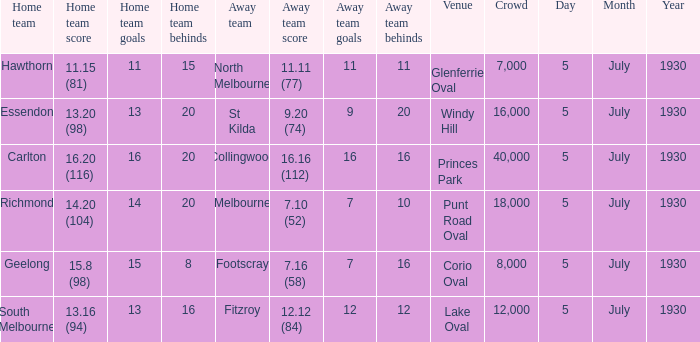When does the team have a game at punt road oval? 5 July 1930. 